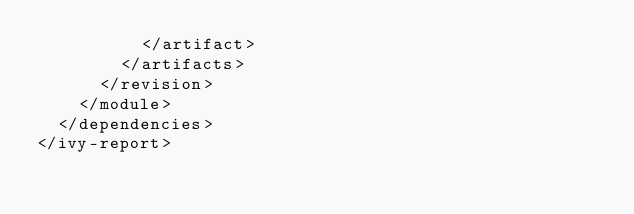<code> <loc_0><loc_0><loc_500><loc_500><_XML_>					</artifact>
				</artifacts>
			</revision>
		</module>
	</dependencies>
</ivy-report>
</code> 